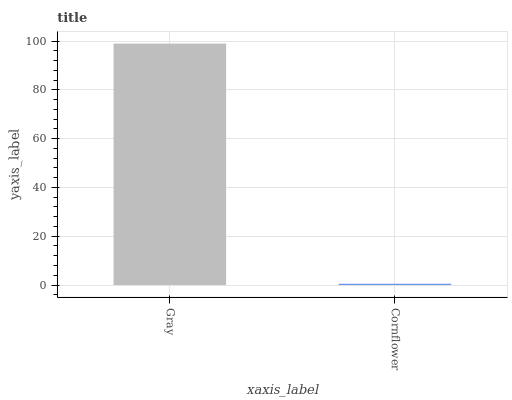Is Cornflower the minimum?
Answer yes or no. Yes. Is Gray the maximum?
Answer yes or no. Yes. Is Cornflower the maximum?
Answer yes or no. No. Is Gray greater than Cornflower?
Answer yes or no. Yes. Is Cornflower less than Gray?
Answer yes or no. Yes. Is Cornflower greater than Gray?
Answer yes or no. No. Is Gray less than Cornflower?
Answer yes or no. No. Is Gray the high median?
Answer yes or no. Yes. Is Cornflower the low median?
Answer yes or no. Yes. Is Cornflower the high median?
Answer yes or no. No. Is Gray the low median?
Answer yes or no. No. 